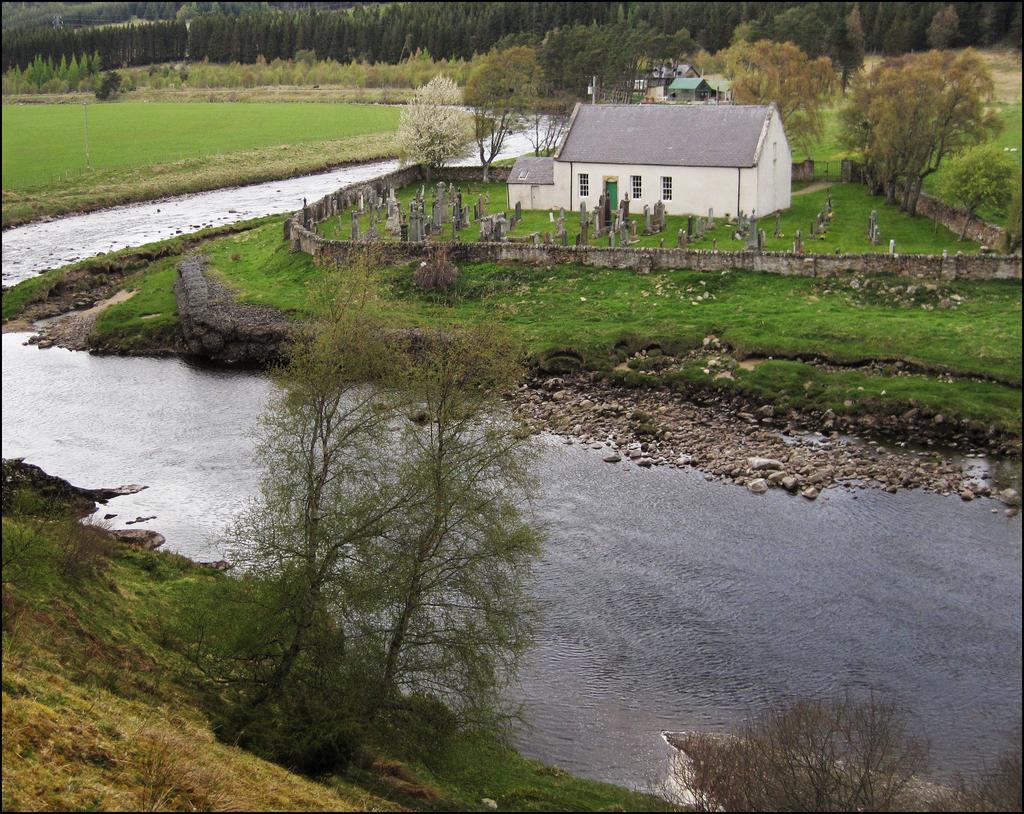Can you describe this image briefly? In this image there is a house beside that there are trees and fence also there is a small lake. 